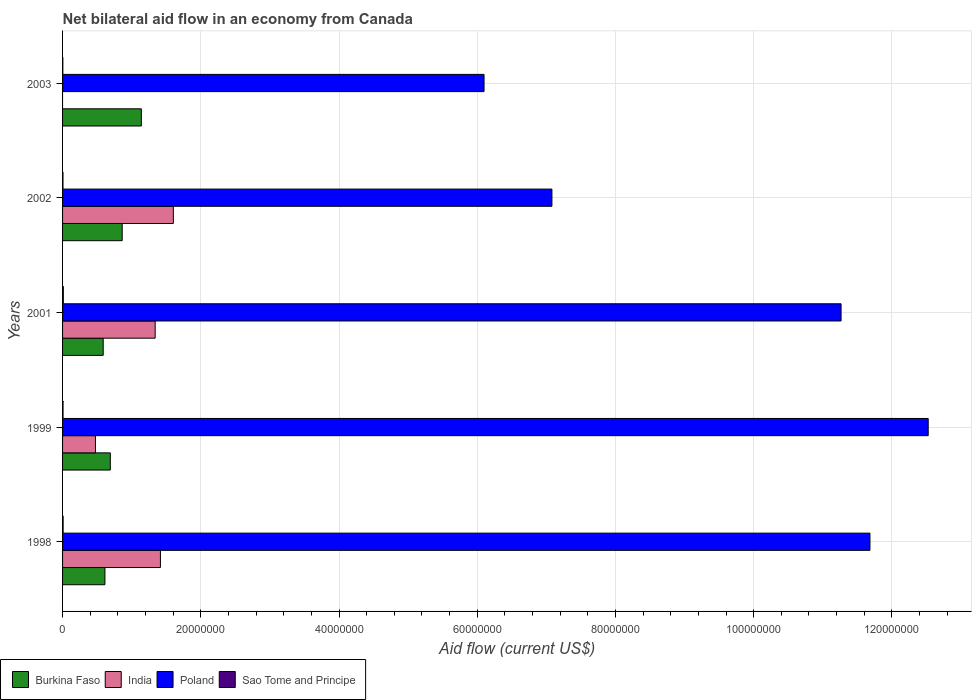How many different coloured bars are there?
Give a very brief answer. 4. How many groups of bars are there?
Your answer should be very brief. 5. In how many cases, is the number of bars for a given year not equal to the number of legend labels?
Provide a short and direct response. 1. What is the net bilateral aid flow in India in 1998?
Offer a terse response. 1.42e+07. Across all years, what is the maximum net bilateral aid flow in India?
Your answer should be very brief. 1.60e+07. Across all years, what is the minimum net bilateral aid flow in Poland?
Provide a succinct answer. 6.10e+07. In which year was the net bilateral aid flow in Poland maximum?
Offer a terse response. 1999. What is the total net bilateral aid flow in Poland in the graph?
Offer a very short reply. 4.87e+08. What is the difference between the net bilateral aid flow in Sao Tome and Principe in 1998 and that in 2003?
Provide a succinct answer. 4.00e+04. What is the difference between the net bilateral aid flow in Sao Tome and Principe in 1998 and the net bilateral aid flow in Poland in 2003?
Provide a succinct answer. -6.09e+07. What is the average net bilateral aid flow in India per year?
Provide a short and direct response. 9.67e+06. In the year 2003, what is the difference between the net bilateral aid flow in Burkina Faso and net bilateral aid flow in Poland?
Make the answer very short. -4.96e+07. What is the ratio of the net bilateral aid flow in Sao Tome and Principe in 2001 to that in 2003?
Give a very brief answer. 2.75. Is the net bilateral aid flow in Poland in 1998 less than that in 2003?
Your response must be concise. No. Is the difference between the net bilateral aid flow in Burkina Faso in 1998 and 2001 greater than the difference between the net bilateral aid flow in Poland in 1998 and 2001?
Your response must be concise. No. What is the difference between the highest and the second highest net bilateral aid flow in India?
Keep it short and to the point. 1.87e+06. What is the difference between the highest and the lowest net bilateral aid flow in India?
Provide a succinct answer. 1.60e+07. In how many years, is the net bilateral aid flow in Poland greater than the average net bilateral aid flow in Poland taken over all years?
Give a very brief answer. 3. Is the sum of the net bilateral aid flow in Sao Tome and Principe in 1998 and 2001 greater than the maximum net bilateral aid flow in Poland across all years?
Make the answer very short. No. Is it the case that in every year, the sum of the net bilateral aid flow in Burkina Faso and net bilateral aid flow in India is greater than the sum of net bilateral aid flow in Sao Tome and Principe and net bilateral aid flow in Poland?
Ensure brevity in your answer.  No. How many bars are there?
Keep it short and to the point. 19. Are all the bars in the graph horizontal?
Give a very brief answer. Yes. Are the values on the major ticks of X-axis written in scientific E-notation?
Offer a terse response. No. Does the graph contain any zero values?
Keep it short and to the point. Yes. Does the graph contain grids?
Keep it short and to the point. Yes. What is the title of the graph?
Give a very brief answer. Net bilateral aid flow in an economy from Canada. What is the Aid flow (current US$) of Burkina Faso in 1998?
Keep it short and to the point. 6.13e+06. What is the Aid flow (current US$) of India in 1998?
Ensure brevity in your answer.  1.42e+07. What is the Aid flow (current US$) in Poland in 1998?
Your response must be concise. 1.17e+08. What is the Aid flow (current US$) of Sao Tome and Principe in 1998?
Offer a terse response. 8.00e+04. What is the Aid flow (current US$) in Burkina Faso in 1999?
Give a very brief answer. 6.91e+06. What is the Aid flow (current US$) of India in 1999?
Ensure brevity in your answer.  4.76e+06. What is the Aid flow (current US$) in Poland in 1999?
Your response must be concise. 1.25e+08. What is the Aid flow (current US$) in Sao Tome and Principe in 1999?
Provide a succinct answer. 7.00e+04. What is the Aid flow (current US$) in Burkina Faso in 2001?
Your answer should be very brief. 5.88e+06. What is the Aid flow (current US$) in India in 2001?
Provide a succinct answer. 1.34e+07. What is the Aid flow (current US$) in Poland in 2001?
Your answer should be very brief. 1.13e+08. What is the Aid flow (current US$) of Burkina Faso in 2002?
Offer a terse response. 8.63e+06. What is the Aid flow (current US$) in India in 2002?
Ensure brevity in your answer.  1.60e+07. What is the Aid flow (current US$) of Poland in 2002?
Ensure brevity in your answer.  7.08e+07. What is the Aid flow (current US$) of Burkina Faso in 2003?
Offer a terse response. 1.14e+07. What is the Aid flow (current US$) of Poland in 2003?
Offer a terse response. 6.10e+07. Across all years, what is the maximum Aid flow (current US$) of Burkina Faso?
Provide a short and direct response. 1.14e+07. Across all years, what is the maximum Aid flow (current US$) of India?
Your answer should be very brief. 1.60e+07. Across all years, what is the maximum Aid flow (current US$) of Poland?
Keep it short and to the point. 1.25e+08. Across all years, what is the maximum Aid flow (current US$) in Sao Tome and Principe?
Make the answer very short. 1.10e+05. Across all years, what is the minimum Aid flow (current US$) in Burkina Faso?
Provide a short and direct response. 5.88e+06. Across all years, what is the minimum Aid flow (current US$) in Poland?
Offer a very short reply. 6.10e+07. What is the total Aid flow (current US$) in Burkina Faso in the graph?
Your response must be concise. 3.90e+07. What is the total Aid flow (current US$) of India in the graph?
Make the answer very short. 4.84e+07. What is the total Aid flow (current US$) of Poland in the graph?
Ensure brevity in your answer.  4.87e+08. What is the difference between the Aid flow (current US$) of Burkina Faso in 1998 and that in 1999?
Ensure brevity in your answer.  -7.80e+05. What is the difference between the Aid flow (current US$) in India in 1998 and that in 1999?
Your answer should be compact. 9.40e+06. What is the difference between the Aid flow (current US$) of Poland in 1998 and that in 1999?
Your answer should be very brief. -8.43e+06. What is the difference between the Aid flow (current US$) in India in 1998 and that in 2001?
Provide a short and direct response. 7.60e+05. What is the difference between the Aid flow (current US$) in Poland in 1998 and that in 2001?
Make the answer very short. 4.18e+06. What is the difference between the Aid flow (current US$) in Sao Tome and Principe in 1998 and that in 2001?
Your answer should be compact. -3.00e+04. What is the difference between the Aid flow (current US$) of Burkina Faso in 1998 and that in 2002?
Give a very brief answer. -2.50e+06. What is the difference between the Aid flow (current US$) in India in 1998 and that in 2002?
Offer a very short reply. -1.87e+06. What is the difference between the Aid flow (current US$) in Poland in 1998 and that in 2002?
Ensure brevity in your answer.  4.60e+07. What is the difference between the Aid flow (current US$) in Sao Tome and Principe in 1998 and that in 2002?
Ensure brevity in your answer.  2.00e+04. What is the difference between the Aid flow (current US$) in Burkina Faso in 1998 and that in 2003?
Your answer should be very brief. -5.27e+06. What is the difference between the Aid flow (current US$) of Poland in 1998 and that in 2003?
Offer a very short reply. 5.58e+07. What is the difference between the Aid flow (current US$) in Sao Tome and Principe in 1998 and that in 2003?
Provide a succinct answer. 4.00e+04. What is the difference between the Aid flow (current US$) in Burkina Faso in 1999 and that in 2001?
Provide a succinct answer. 1.03e+06. What is the difference between the Aid flow (current US$) of India in 1999 and that in 2001?
Provide a short and direct response. -8.64e+06. What is the difference between the Aid flow (current US$) in Poland in 1999 and that in 2001?
Give a very brief answer. 1.26e+07. What is the difference between the Aid flow (current US$) in Burkina Faso in 1999 and that in 2002?
Offer a terse response. -1.72e+06. What is the difference between the Aid flow (current US$) in India in 1999 and that in 2002?
Keep it short and to the point. -1.13e+07. What is the difference between the Aid flow (current US$) in Poland in 1999 and that in 2002?
Offer a terse response. 5.44e+07. What is the difference between the Aid flow (current US$) of Sao Tome and Principe in 1999 and that in 2002?
Your answer should be compact. 10000. What is the difference between the Aid flow (current US$) of Burkina Faso in 1999 and that in 2003?
Ensure brevity in your answer.  -4.49e+06. What is the difference between the Aid flow (current US$) in Poland in 1999 and that in 2003?
Offer a terse response. 6.43e+07. What is the difference between the Aid flow (current US$) in Sao Tome and Principe in 1999 and that in 2003?
Make the answer very short. 3.00e+04. What is the difference between the Aid flow (current US$) of Burkina Faso in 2001 and that in 2002?
Your answer should be compact. -2.75e+06. What is the difference between the Aid flow (current US$) of India in 2001 and that in 2002?
Ensure brevity in your answer.  -2.63e+06. What is the difference between the Aid flow (current US$) in Poland in 2001 and that in 2002?
Provide a short and direct response. 4.18e+07. What is the difference between the Aid flow (current US$) of Sao Tome and Principe in 2001 and that in 2002?
Your answer should be very brief. 5.00e+04. What is the difference between the Aid flow (current US$) in Burkina Faso in 2001 and that in 2003?
Your response must be concise. -5.52e+06. What is the difference between the Aid flow (current US$) in Poland in 2001 and that in 2003?
Ensure brevity in your answer.  5.17e+07. What is the difference between the Aid flow (current US$) of Burkina Faso in 2002 and that in 2003?
Offer a very short reply. -2.77e+06. What is the difference between the Aid flow (current US$) of Poland in 2002 and that in 2003?
Offer a terse response. 9.82e+06. What is the difference between the Aid flow (current US$) in Burkina Faso in 1998 and the Aid flow (current US$) in India in 1999?
Your answer should be very brief. 1.37e+06. What is the difference between the Aid flow (current US$) of Burkina Faso in 1998 and the Aid flow (current US$) of Poland in 1999?
Your response must be concise. -1.19e+08. What is the difference between the Aid flow (current US$) in Burkina Faso in 1998 and the Aid flow (current US$) in Sao Tome and Principe in 1999?
Your answer should be very brief. 6.06e+06. What is the difference between the Aid flow (current US$) of India in 1998 and the Aid flow (current US$) of Poland in 1999?
Provide a succinct answer. -1.11e+08. What is the difference between the Aid flow (current US$) of India in 1998 and the Aid flow (current US$) of Sao Tome and Principe in 1999?
Provide a short and direct response. 1.41e+07. What is the difference between the Aid flow (current US$) of Poland in 1998 and the Aid flow (current US$) of Sao Tome and Principe in 1999?
Provide a short and direct response. 1.17e+08. What is the difference between the Aid flow (current US$) of Burkina Faso in 1998 and the Aid flow (current US$) of India in 2001?
Offer a very short reply. -7.27e+06. What is the difference between the Aid flow (current US$) of Burkina Faso in 1998 and the Aid flow (current US$) of Poland in 2001?
Provide a short and direct response. -1.07e+08. What is the difference between the Aid flow (current US$) in Burkina Faso in 1998 and the Aid flow (current US$) in Sao Tome and Principe in 2001?
Your response must be concise. 6.02e+06. What is the difference between the Aid flow (current US$) of India in 1998 and the Aid flow (current US$) of Poland in 2001?
Ensure brevity in your answer.  -9.85e+07. What is the difference between the Aid flow (current US$) in India in 1998 and the Aid flow (current US$) in Sao Tome and Principe in 2001?
Your answer should be very brief. 1.40e+07. What is the difference between the Aid flow (current US$) of Poland in 1998 and the Aid flow (current US$) of Sao Tome and Principe in 2001?
Ensure brevity in your answer.  1.17e+08. What is the difference between the Aid flow (current US$) of Burkina Faso in 1998 and the Aid flow (current US$) of India in 2002?
Your response must be concise. -9.90e+06. What is the difference between the Aid flow (current US$) of Burkina Faso in 1998 and the Aid flow (current US$) of Poland in 2002?
Provide a short and direct response. -6.47e+07. What is the difference between the Aid flow (current US$) in Burkina Faso in 1998 and the Aid flow (current US$) in Sao Tome and Principe in 2002?
Offer a terse response. 6.07e+06. What is the difference between the Aid flow (current US$) of India in 1998 and the Aid flow (current US$) of Poland in 2002?
Keep it short and to the point. -5.66e+07. What is the difference between the Aid flow (current US$) in India in 1998 and the Aid flow (current US$) in Sao Tome and Principe in 2002?
Keep it short and to the point. 1.41e+07. What is the difference between the Aid flow (current US$) of Poland in 1998 and the Aid flow (current US$) of Sao Tome and Principe in 2002?
Offer a very short reply. 1.17e+08. What is the difference between the Aid flow (current US$) in Burkina Faso in 1998 and the Aid flow (current US$) in Poland in 2003?
Keep it short and to the point. -5.49e+07. What is the difference between the Aid flow (current US$) of Burkina Faso in 1998 and the Aid flow (current US$) of Sao Tome and Principe in 2003?
Keep it short and to the point. 6.09e+06. What is the difference between the Aid flow (current US$) in India in 1998 and the Aid flow (current US$) in Poland in 2003?
Your answer should be compact. -4.68e+07. What is the difference between the Aid flow (current US$) of India in 1998 and the Aid flow (current US$) of Sao Tome and Principe in 2003?
Your response must be concise. 1.41e+07. What is the difference between the Aid flow (current US$) of Poland in 1998 and the Aid flow (current US$) of Sao Tome and Principe in 2003?
Your answer should be very brief. 1.17e+08. What is the difference between the Aid flow (current US$) in Burkina Faso in 1999 and the Aid flow (current US$) in India in 2001?
Provide a short and direct response. -6.49e+06. What is the difference between the Aid flow (current US$) of Burkina Faso in 1999 and the Aid flow (current US$) of Poland in 2001?
Your answer should be compact. -1.06e+08. What is the difference between the Aid flow (current US$) in Burkina Faso in 1999 and the Aid flow (current US$) in Sao Tome and Principe in 2001?
Give a very brief answer. 6.80e+06. What is the difference between the Aid flow (current US$) in India in 1999 and the Aid flow (current US$) in Poland in 2001?
Keep it short and to the point. -1.08e+08. What is the difference between the Aid flow (current US$) in India in 1999 and the Aid flow (current US$) in Sao Tome and Principe in 2001?
Provide a short and direct response. 4.65e+06. What is the difference between the Aid flow (current US$) of Poland in 1999 and the Aid flow (current US$) of Sao Tome and Principe in 2001?
Your answer should be compact. 1.25e+08. What is the difference between the Aid flow (current US$) in Burkina Faso in 1999 and the Aid flow (current US$) in India in 2002?
Make the answer very short. -9.12e+06. What is the difference between the Aid flow (current US$) in Burkina Faso in 1999 and the Aid flow (current US$) in Poland in 2002?
Your response must be concise. -6.39e+07. What is the difference between the Aid flow (current US$) of Burkina Faso in 1999 and the Aid flow (current US$) of Sao Tome and Principe in 2002?
Offer a terse response. 6.85e+06. What is the difference between the Aid flow (current US$) of India in 1999 and the Aid flow (current US$) of Poland in 2002?
Offer a terse response. -6.60e+07. What is the difference between the Aid flow (current US$) in India in 1999 and the Aid flow (current US$) in Sao Tome and Principe in 2002?
Offer a very short reply. 4.70e+06. What is the difference between the Aid flow (current US$) in Poland in 1999 and the Aid flow (current US$) in Sao Tome and Principe in 2002?
Your response must be concise. 1.25e+08. What is the difference between the Aid flow (current US$) of Burkina Faso in 1999 and the Aid flow (current US$) of Poland in 2003?
Your response must be concise. -5.41e+07. What is the difference between the Aid flow (current US$) of Burkina Faso in 1999 and the Aid flow (current US$) of Sao Tome and Principe in 2003?
Your response must be concise. 6.87e+06. What is the difference between the Aid flow (current US$) in India in 1999 and the Aid flow (current US$) in Poland in 2003?
Your answer should be very brief. -5.62e+07. What is the difference between the Aid flow (current US$) in India in 1999 and the Aid flow (current US$) in Sao Tome and Principe in 2003?
Offer a terse response. 4.72e+06. What is the difference between the Aid flow (current US$) in Poland in 1999 and the Aid flow (current US$) in Sao Tome and Principe in 2003?
Your response must be concise. 1.25e+08. What is the difference between the Aid flow (current US$) of Burkina Faso in 2001 and the Aid flow (current US$) of India in 2002?
Your answer should be compact. -1.02e+07. What is the difference between the Aid flow (current US$) of Burkina Faso in 2001 and the Aid flow (current US$) of Poland in 2002?
Ensure brevity in your answer.  -6.49e+07. What is the difference between the Aid flow (current US$) of Burkina Faso in 2001 and the Aid flow (current US$) of Sao Tome and Principe in 2002?
Give a very brief answer. 5.82e+06. What is the difference between the Aid flow (current US$) in India in 2001 and the Aid flow (current US$) in Poland in 2002?
Provide a short and direct response. -5.74e+07. What is the difference between the Aid flow (current US$) in India in 2001 and the Aid flow (current US$) in Sao Tome and Principe in 2002?
Offer a terse response. 1.33e+07. What is the difference between the Aid flow (current US$) in Poland in 2001 and the Aid flow (current US$) in Sao Tome and Principe in 2002?
Provide a short and direct response. 1.13e+08. What is the difference between the Aid flow (current US$) of Burkina Faso in 2001 and the Aid flow (current US$) of Poland in 2003?
Keep it short and to the point. -5.51e+07. What is the difference between the Aid flow (current US$) of Burkina Faso in 2001 and the Aid flow (current US$) of Sao Tome and Principe in 2003?
Provide a short and direct response. 5.84e+06. What is the difference between the Aid flow (current US$) in India in 2001 and the Aid flow (current US$) in Poland in 2003?
Ensure brevity in your answer.  -4.76e+07. What is the difference between the Aid flow (current US$) in India in 2001 and the Aid flow (current US$) in Sao Tome and Principe in 2003?
Give a very brief answer. 1.34e+07. What is the difference between the Aid flow (current US$) of Poland in 2001 and the Aid flow (current US$) of Sao Tome and Principe in 2003?
Provide a short and direct response. 1.13e+08. What is the difference between the Aid flow (current US$) in Burkina Faso in 2002 and the Aid flow (current US$) in Poland in 2003?
Offer a terse response. -5.24e+07. What is the difference between the Aid flow (current US$) in Burkina Faso in 2002 and the Aid flow (current US$) in Sao Tome and Principe in 2003?
Offer a terse response. 8.59e+06. What is the difference between the Aid flow (current US$) in India in 2002 and the Aid flow (current US$) in Poland in 2003?
Your answer should be very brief. -4.50e+07. What is the difference between the Aid flow (current US$) in India in 2002 and the Aid flow (current US$) in Sao Tome and Principe in 2003?
Your answer should be compact. 1.60e+07. What is the difference between the Aid flow (current US$) in Poland in 2002 and the Aid flow (current US$) in Sao Tome and Principe in 2003?
Ensure brevity in your answer.  7.08e+07. What is the average Aid flow (current US$) of Burkina Faso per year?
Provide a short and direct response. 7.79e+06. What is the average Aid flow (current US$) of India per year?
Your response must be concise. 9.67e+06. What is the average Aid flow (current US$) in Poland per year?
Keep it short and to the point. 9.73e+07. What is the average Aid flow (current US$) in Sao Tome and Principe per year?
Ensure brevity in your answer.  7.20e+04. In the year 1998, what is the difference between the Aid flow (current US$) of Burkina Faso and Aid flow (current US$) of India?
Your response must be concise. -8.03e+06. In the year 1998, what is the difference between the Aid flow (current US$) of Burkina Faso and Aid flow (current US$) of Poland?
Offer a very short reply. -1.11e+08. In the year 1998, what is the difference between the Aid flow (current US$) of Burkina Faso and Aid flow (current US$) of Sao Tome and Principe?
Offer a very short reply. 6.05e+06. In the year 1998, what is the difference between the Aid flow (current US$) of India and Aid flow (current US$) of Poland?
Your response must be concise. -1.03e+08. In the year 1998, what is the difference between the Aid flow (current US$) in India and Aid flow (current US$) in Sao Tome and Principe?
Offer a terse response. 1.41e+07. In the year 1998, what is the difference between the Aid flow (current US$) of Poland and Aid flow (current US$) of Sao Tome and Principe?
Offer a terse response. 1.17e+08. In the year 1999, what is the difference between the Aid flow (current US$) of Burkina Faso and Aid flow (current US$) of India?
Your answer should be very brief. 2.15e+06. In the year 1999, what is the difference between the Aid flow (current US$) of Burkina Faso and Aid flow (current US$) of Poland?
Give a very brief answer. -1.18e+08. In the year 1999, what is the difference between the Aid flow (current US$) in Burkina Faso and Aid flow (current US$) in Sao Tome and Principe?
Give a very brief answer. 6.84e+06. In the year 1999, what is the difference between the Aid flow (current US$) of India and Aid flow (current US$) of Poland?
Keep it short and to the point. -1.20e+08. In the year 1999, what is the difference between the Aid flow (current US$) of India and Aid flow (current US$) of Sao Tome and Principe?
Give a very brief answer. 4.69e+06. In the year 1999, what is the difference between the Aid flow (current US$) of Poland and Aid flow (current US$) of Sao Tome and Principe?
Offer a very short reply. 1.25e+08. In the year 2001, what is the difference between the Aid flow (current US$) of Burkina Faso and Aid flow (current US$) of India?
Ensure brevity in your answer.  -7.52e+06. In the year 2001, what is the difference between the Aid flow (current US$) in Burkina Faso and Aid flow (current US$) in Poland?
Your response must be concise. -1.07e+08. In the year 2001, what is the difference between the Aid flow (current US$) in Burkina Faso and Aid flow (current US$) in Sao Tome and Principe?
Offer a terse response. 5.77e+06. In the year 2001, what is the difference between the Aid flow (current US$) of India and Aid flow (current US$) of Poland?
Keep it short and to the point. -9.92e+07. In the year 2001, what is the difference between the Aid flow (current US$) in India and Aid flow (current US$) in Sao Tome and Principe?
Offer a terse response. 1.33e+07. In the year 2001, what is the difference between the Aid flow (current US$) of Poland and Aid flow (current US$) of Sao Tome and Principe?
Give a very brief answer. 1.13e+08. In the year 2002, what is the difference between the Aid flow (current US$) in Burkina Faso and Aid flow (current US$) in India?
Make the answer very short. -7.40e+06. In the year 2002, what is the difference between the Aid flow (current US$) of Burkina Faso and Aid flow (current US$) of Poland?
Provide a succinct answer. -6.22e+07. In the year 2002, what is the difference between the Aid flow (current US$) of Burkina Faso and Aid flow (current US$) of Sao Tome and Principe?
Give a very brief answer. 8.57e+06. In the year 2002, what is the difference between the Aid flow (current US$) in India and Aid flow (current US$) in Poland?
Provide a succinct answer. -5.48e+07. In the year 2002, what is the difference between the Aid flow (current US$) in India and Aid flow (current US$) in Sao Tome and Principe?
Keep it short and to the point. 1.60e+07. In the year 2002, what is the difference between the Aid flow (current US$) in Poland and Aid flow (current US$) in Sao Tome and Principe?
Offer a very short reply. 7.08e+07. In the year 2003, what is the difference between the Aid flow (current US$) in Burkina Faso and Aid flow (current US$) in Poland?
Make the answer very short. -4.96e+07. In the year 2003, what is the difference between the Aid flow (current US$) of Burkina Faso and Aid flow (current US$) of Sao Tome and Principe?
Make the answer very short. 1.14e+07. In the year 2003, what is the difference between the Aid flow (current US$) of Poland and Aid flow (current US$) of Sao Tome and Principe?
Keep it short and to the point. 6.10e+07. What is the ratio of the Aid flow (current US$) of Burkina Faso in 1998 to that in 1999?
Give a very brief answer. 0.89. What is the ratio of the Aid flow (current US$) in India in 1998 to that in 1999?
Provide a short and direct response. 2.97. What is the ratio of the Aid flow (current US$) of Poland in 1998 to that in 1999?
Ensure brevity in your answer.  0.93. What is the ratio of the Aid flow (current US$) in Burkina Faso in 1998 to that in 2001?
Offer a very short reply. 1.04. What is the ratio of the Aid flow (current US$) of India in 1998 to that in 2001?
Ensure brevity in your answer.  1.06. What is the ratio of the Aid flow (current US$) of Poland in 1998 to that in 2001?
Make the answer very short. 1.04. What is the ratio of the Aid flow (current US$) of Sao Tome and Principe in 1998 to that in 2001?
Your response must be concise. 0.73. What is the ratio of the Aid flow (current US$) in Burkina Faso in 1998 to that in 2002?
Give a very brief answer. 0.71. What is the ratio of the Aid flow (current US$) in India in 1998 to that in 2002?
Offer a terse response. 0.88. What is the ratio of the Aid flow (current US$) in Poland in 1998 to that in 2002?
Give a very brief answer. 1.65. What is the ratio of the Aid flow (current US$) in Burkina Faso in 1998 to that in 2003?
Your answer should be compact. 0.54. What is the ratio of the Aid flow (current US$) in Poland in 1998 to that in 2003?
Your answer should be very brief. 1.92. What is the ratio of the Aid flow (current US$) in Burkina Faso in 1999 to that in 2001?
Offer a very short reply. 1.18. What is the ratio of the Aid flow (current US$) of India in 1999 to that in 2001?
Your response must be concise. 0.36. What is the ratio of the Aid flow (current US$) of Poland in 1999 to that in 2001?
Keep it short and to the point. 1.11. What is the ratio of the Aid flow (current US$) in Sao Tome and Principe in 1999 to that in 2001?
Offer a very short reply. 0.64. What is the ratio of the Aid flow (current US$) in Burkina Faso in 1999 to that in 2002?
Offer a terse response. 0.8. What is the ratio of the Aid flow (current US$) in India in 1999 to that in 2002?
Your answer should be compact. 0.3. What is the ratio of the Aid flow (current US$) in Poland in 1999 to that in 2002?
Your answer should be very brief. 1.77. What is the ratio of the Aid flow (current US$) in Sao Tome and Principe in 1999 to that in 2002?
Offer a very short reply. 1.17. What is the ratio of the Aid flow (current US$) of Burkina Faso in 1999 to that in 2003?
Keep it short and to the point. 0.61. What is the ratio of the Aid flow (current US$) of Poland in 1999 to that in 2003?
Provide a succinct answer. 2.05. What is the ratio of the Aid flow (current US$) in Burkina Faso in 2001 to that in 2002?
Your answer should be compact. 0.68. What is the ratio of the Aid flow (current US$) of India in 2001 to that in 2002?
Give a very brief answer. 0.84. What is the ratio of the Aid flow (current US$) of Poland in 2001 to that in 2002?
Provide a succinct answer. 1.59. What is the ratio of the Aid flow (current US$) in Sao Tome and Principe in 2001 to that in 2002?
Your response must be concise. 1.83. What is the ratio of the Aid flow (current US$) of Burkina Faso in 2001 to that in 2003?
Offer a very short reply. 0.52. What is the ratio of the Aid flow (current US$) in Poland in 2001 to that in 2003?
Ensure brevity in your answer.  1.85. What is the ratio of the Aid flow (current US$) in Sao Tome and Principe in 2001 to that in 2003?
Give a very brief answer. 2.75. What is the ratio of the Aid flow (current US$) in Burkina Faso in 2002 to that in 2003?
Offer a very short reply. 0.76. What is the ratio of the Aid flow (current US$) of Poland in 2002 to that in 2003?
Offer a very short reply. 1.16. What is the difference between the highest and the second highest Aid flow (current US$) in Burkina Faso?
Your answer should be very brief. 2.77e+06. What is the difference between the highest and the second highest Aid flow (current US$) of India?
Provide a succinct answer. 1.87e+06. What is the difference between the highest and the second highest Aid flow (current US$) in Poland?
Your answer should be very brief. 8.43e+06. What is the difference between the highest and the second highest Aid flow (current US$) of Sao Tome and Principe?
Offer a very short reply. 3.00e+04. What is the difference between the highest and the lowest Aid flow (current US$) in Burkina Faso?
Provide a succinct answer. 5.52e+06. What is the difference between the highest and the lowest Aid flow (current US$) of India?
Keep it short and to the point. 1.60e+07. What is the difference between the highest and the lowest Aid flow (current US$) in Poland?
Your response must be concise. 6.43e+07. 